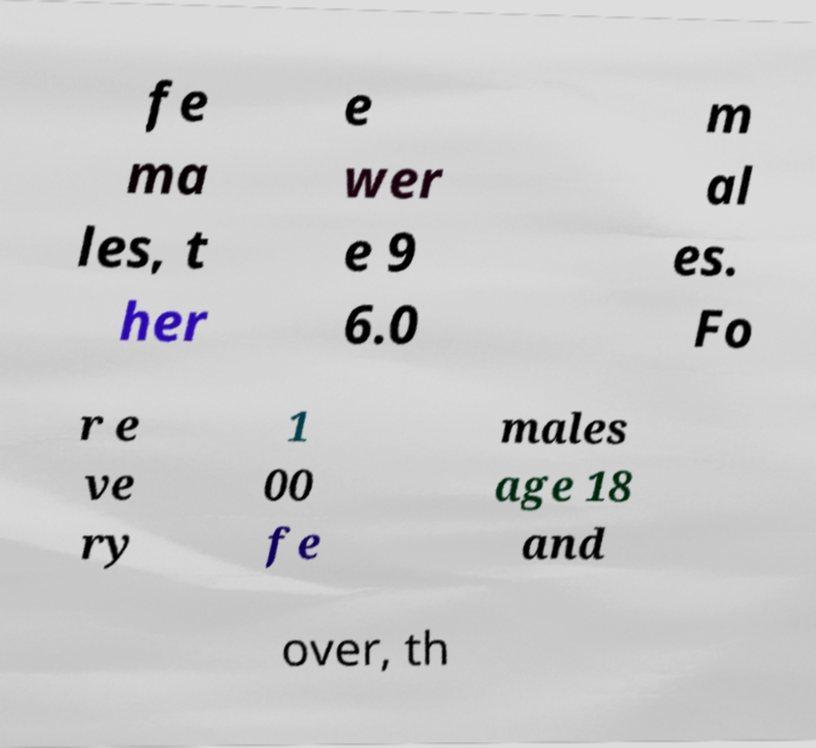Could you extract and type out the text from this image? fe ma les, t her e wer e 9 6.0 m al es. Fo r e ve ry 1 00 fe males age 18 and over, th 